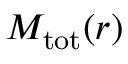<formula> <loc_0><loc_0><loc_500><loc_500>M _ { t o t } ( r )</formula> 